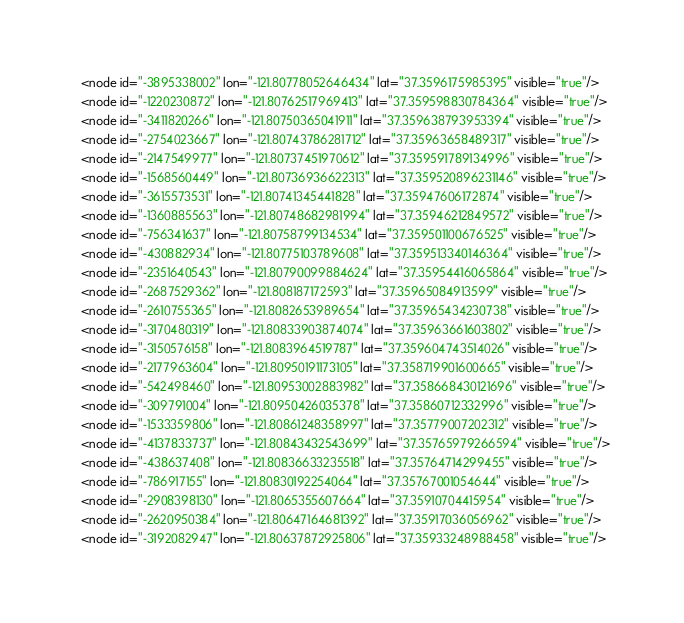Convert code to text. <code><loc_0><loc_0><loc_500><loc_500><_XML_>  <node id="-3895338002" lon="-121.80778052646434" lat="37.3596175985395" visible="true"/>
  <node id="-1220230872" lon="-121.80762517969413" lat="37.359598830784364" visible="true"/>
  <node id="-3411820266" lon="-121.80750365041911" lat="37.359638793953394" visible="true"/>
  <node id="-2754023667" lon="-121.80743786281712" lat="37.35963658489317" visible="true"/>
  <node id="-2147549977" lon="-121.80737451970612" lat="37.359591789134996" visible="true"/>
  <node id="-1568560449" lon="-121.80736936622313" lat="37.359520896231146" visible="true"/>
  <node id="-3615573531" lon="-121.80741345441828" lat="37.35947606172874" visible="true"/>
  <node id="-1360885563" lon="-121.80748682981994" lat="37.35946212849572" visible="true"/>
  <node id="-756341637" lon="-121.80758799134534" lat="37.359501100676525" visible="true"/>
  <node id="-430882934" lon="-121.80775103789608" lat="37.359513340146364" visible="true"/>
  <node id="-2351640543" lon="-121.80790099884624" lat="37.35954416065864" visible="true"/>
  <node id="-2687529362" lon="-121.808187172593" lat="37.35965084913599" visible="true"/>
  <node id="-2610755365" lon="-121.8082653989654" lat="37.35965434230738" visible="true"/>
  <node id="-3170480319" lon="-121.80833903874074" lat="37.35963661603802" visible="true"/>
  <node id="-3150576158" lon="-121.8083964519787" lat="37.359604743514026" visible="true"/>
  <node id="-2177963604" lon="-121.80950191173105" lat="37.358719901600665" visible="true"/>
  <node id="-542498460" lon="-121.80953002883982" lat="37.358668430121696" visible="true"/>
  <node id="-309791004" lon="-121.80950426035378" lat="37.35860712332996" visible="true"/>
  <node id="-1533359806" lon="-121.80861248358997" lat="37.35779007202312" visible="true"/>
  <node id="-4137833737" lon="-121.80843432543699" lat="37.35765979266594" visible="true"/>
  <node id="-438637408" lon="-121.80836633235518" lat="37.35764714299455" visible="true"/>
  <node id="-786917155" lon="-121.80830192254064" lat="37.35767001054644" visible="true"/>
  <node id="-2908398130" lon="-121.8065355607664" lat="37.35910704415954" visible="true"/>
  <node id="-2620950384" lon="-121.80647164681392" lat="37.35917036056962" visible="true"/>
  <node id="-3192082947" lon="-121.80637872925806" lat="37.35933248988458" visible="true"/></code> 